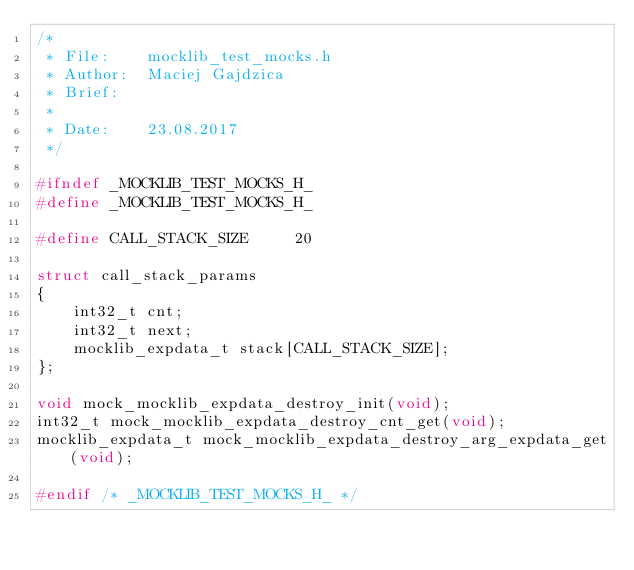Convert code to text. <code><loc_0><loc_0><loc_500><loc_500><_C_>/*
 * File:    mocklib_test_mocks.h
 * Author:  Maciej Gajdzica
 * Brief:
 *
 * Date:    23.08.2017
 */

#ifndef _MOCKLIB_TEST_MOCKS_H_
#define _MOCKLIB_TEST_MOCKS_H_

#define CALL_STACK_SIZE     20

struct call_stack_params
{
    int32_t cnt;
    int32_t next;
    mocklib_expdata_t stack[CALL_STACK_SIZE];
};

void mock_mocklib_expdata_destroy_init(void);
int32_t mock_mocklib_expdata_destroy_cnt_get(void);
mocklib_expdata_t mock_mocklib_expdata_destroy_arg_expdata_get(void);

#endif /* _MOCKLIB_TEST_MOCKS_H_ */
</code> 